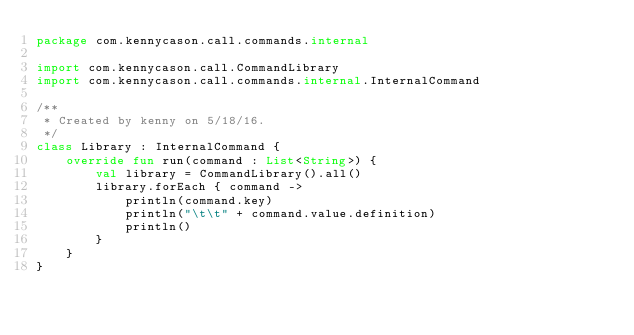<code> <loc_0><loc_0><loc_500><loc_500><_Kotlin_>package com.kennycason.call.commands.internal

import com.kennycason.call.CommandLibrary
import com.kennycason.call.commands.internal.InternalCommand

/**
 * Created by kenny on 5/18/16.
 */
class Library : InternalCommand {
    override fun run(command : List<String>) {
        val library = CommandLibrary().all()
        library.forEach { command ->
            println(command.key)
            println("\t\t" + command.value.definition)
            println()
        }
    }
}</code> 